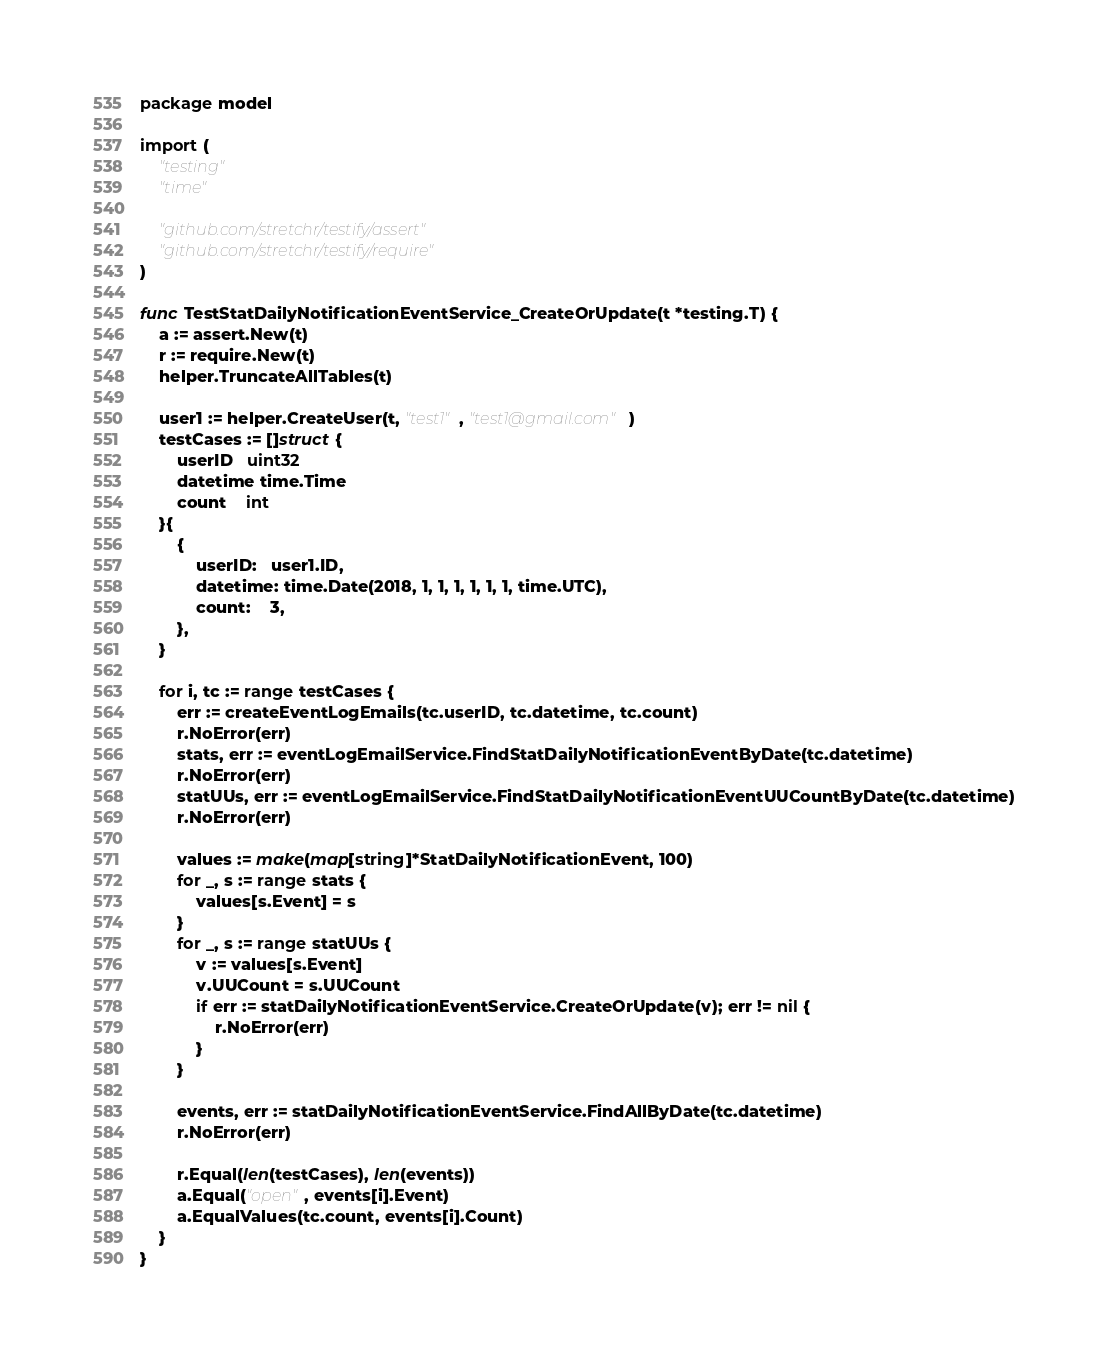<code> <loc_0><loc_0><loc_500><loc_500><_Go_>package model

import (
	"testing"
	"time"

	"github.com/stretchr/testify/assert"
	"github.com/stretchr/testify/require"
)

func TestStatDailyNotificationEventService_CreateOrUpdate(t *testing.T) {
	a := assert.New(t)
	r := require.New(t)
	helper.TruncateAllTables(t)

	user1 := helper.CreateUser(t, "test1", "test1@gmail.com")
	testCases := []struct {
		userID   uint32
		datetime time.Time
		count    int
	}{
		{
			userID:   user1.ID,
			datetime: time.Date(2018, 1, 1, 1, 1, 1, 1, time.UTC),
			count:    3,
		},
	}

	for i, tc := range testCases {
		err := createEventLogEmails(tc.userID, tc.datetime, tc.count)
		r.NoError(err)
		stats, err := eventLogEmailService.FindStatDailyNotificationEventByDate(tc.datetime)
		r.NoError(err)
		statUUs, err := eventLogEmailService.FindStatDailyNotificationEventUUCountByDate(tc.datetime)
		r.NoError(err)

		values := make(map[string]*StatDailyNotificationEvent, 100)
		for _, s := range stats {
			values[s.Event] = s
		}
		for _, s := range statUUs {
			v := values[s.Event]
			v.UUCount = s.UUCount
			if err := statDailyNotificationEventService.CreateOrUpdate(v); err != nil {
				r.NoError(err)
			}
		}

		events, err := statDailyNotificationEventService.FindAllByDate(tc.datetime)
		r.NoError(err)

		r.Equal(len(testCases), len(events))
		a.Equal("open", events[i].Event)
		a.EqualValues(tc.count, events[i].Count)
	}
}
</code> 